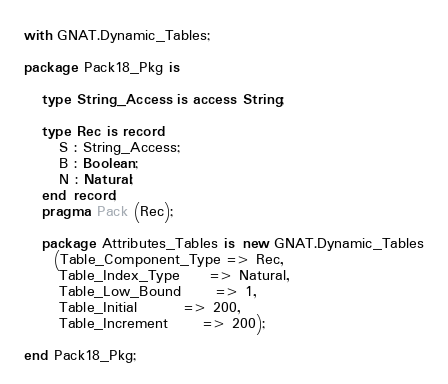Convert code to text. <code><loc_0><loc_0><loc_500><loc_500><_Ada_>with GNAT.Dynamic_Tables;

package Pack18_Pkg is

   type String_Access is access String;

   type Rec is record
      S : String_Access;
      B : Boolean;
      N : Natural;
   end record;
   pragma Pack (Rec);

   package Attributes_Tables is new GNAT.Dynamic_Tables
     (Table_Component_Type => Rec,
      Table_Index_Type     => Natural,
      Table_Low_Bound      => 1,
      Table_Initial        => 200,
      Table_Increment      => 200);

end Pack18_Pkg;
</code> 